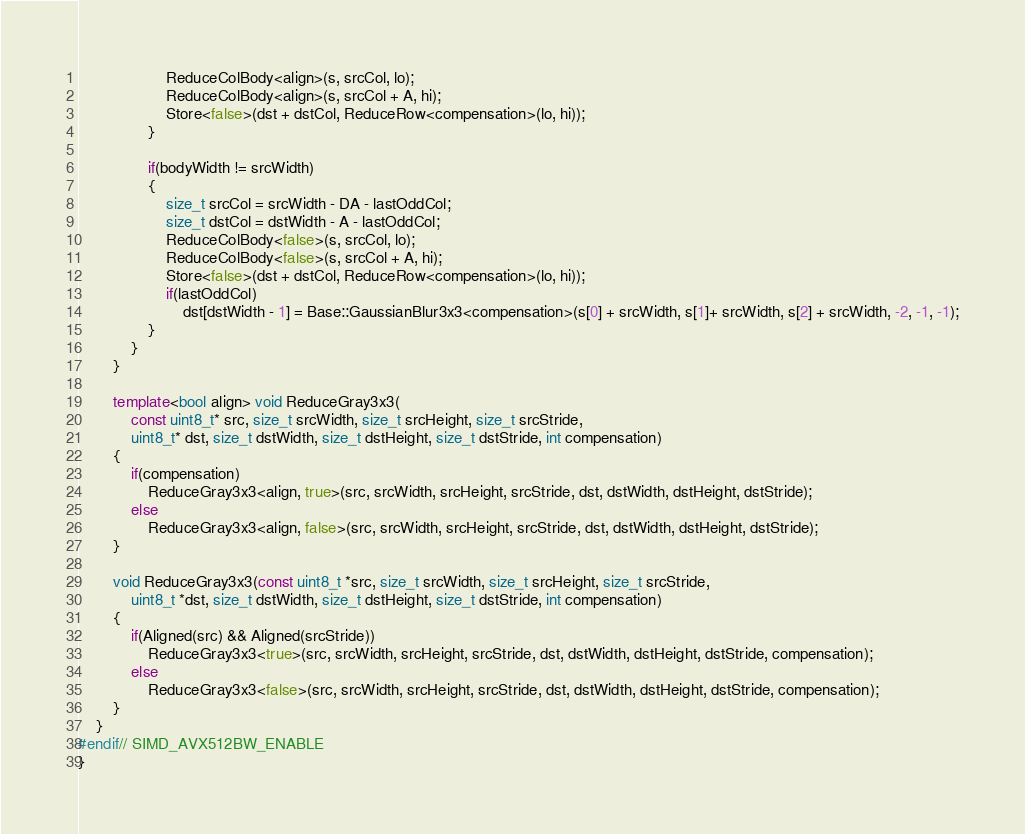Convert code to text. <code><loc_0><loc_0><loc_500><loc_500><_C++_>                    ReduceColBody<align>(s, srcCol, lo);
                    ReduceColBody<align>(s, srcCol + A, hi);
                    Store<false>(dst + dstCol, ReduceRow<compensation>(lo, hi));
                }

                if(bodyWidth != srcWidth)
                {
                    size_t srcCol = srcWidth - DA - lastOddCol;
                    size_t dstCol = dstWidth - A - lastOddCol;
                    ReduceColBody<false>(s, srcCol, lo);
                    ReduceColBody<false>(s, srcCol + A, hi);
                    Store<false>(dst + dstCol, ReduceRow<compensation>(lo, hi));
                    if(lastOddCol)
                        dst[dstWidth - 1] = Base::GaussianBlur3x3<compensation>(s[0] + srcWidth, s[1]+ srcWidth, s[2] + srcWidth, -2, -1, -1);
                }
            }
        }

        template<bool align> void ReduceGray3x3(
            const uint8_t* src, size_t srcWidth, size_t srcHeight, size_t srcStride,
            uint8_t* dst, size_t dstWidth, size_t dstHeight, size_t dstStride, int compensation)	
        {
            if(compensation)
                ReduceGray3x3<align, true>(src, srcWidth, srcHeight, srcStride, dst, dstWidth, dstHeight, dstStride);
            else
                ReduceGray3x3<align, false>(src, srcWidth, srcHeight, srcStride, dst, dstWidth, dstHeight, dstStride);
        }

        void ReduceGray3x3(const uint8_t *src, size_t srcWidth, size_t srcHeight, size_t srcStride, 
            uint8_t *dst, size_t dstWidth, size_t dstHeight, size_t dstStride, int compensation)
        {
            if(Aligned(src) && Aligned(srcStride))
                ReduceGray3x3<true>(src, srcWidth, srcHeight, srcStride, dst, dstWidth, dstHeight, dstStride, compensation);
            else
                ReduceGray3x3<false>(src, srcWidth, srcHeight, srcStride, dst, dstWidth, dstHeight, dstStride, compensation);
        }
    }
#endif// SIMD_AVX512BW_ENABLE
}
</code> 